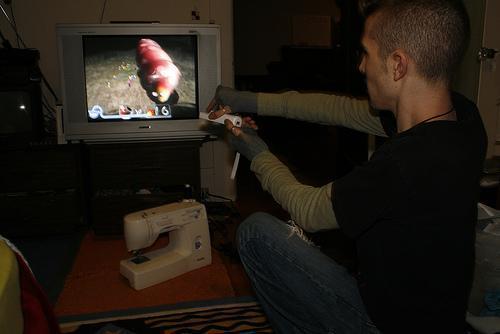How many people are in the photo?
Give a very brief answer. 1. 